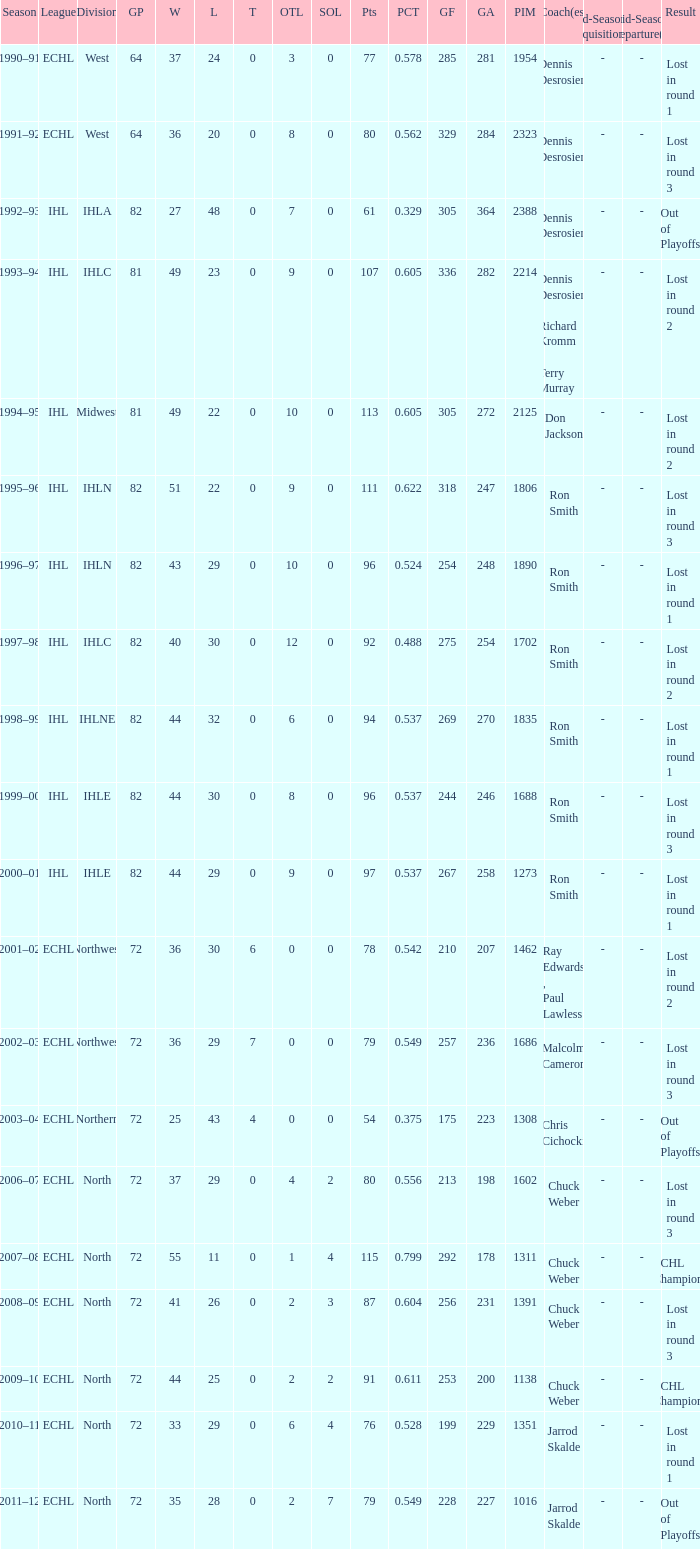What was the maximum OTL if L is 28? 2.0. 